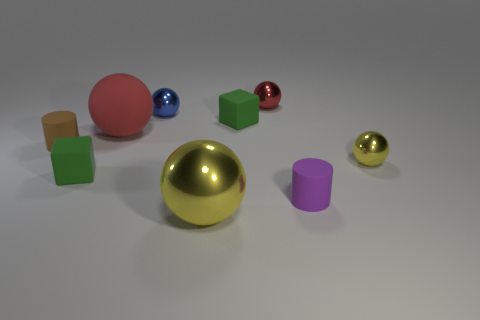What number of small objects are rubber things or yellow cylinders? In the image, there is one yellow cylinder and three small rubber balls of different colors, making a total of four items that fit the criteria. 